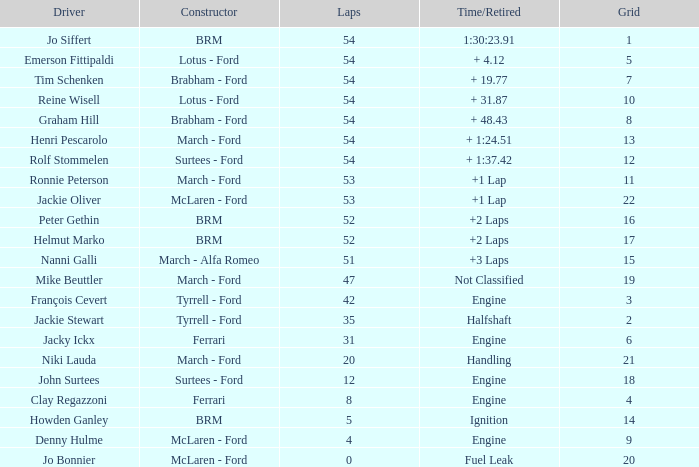What is the average grid that has over 8 laps, a Time/Retired of +2 laps, and peter gethin driving? 16.0. 